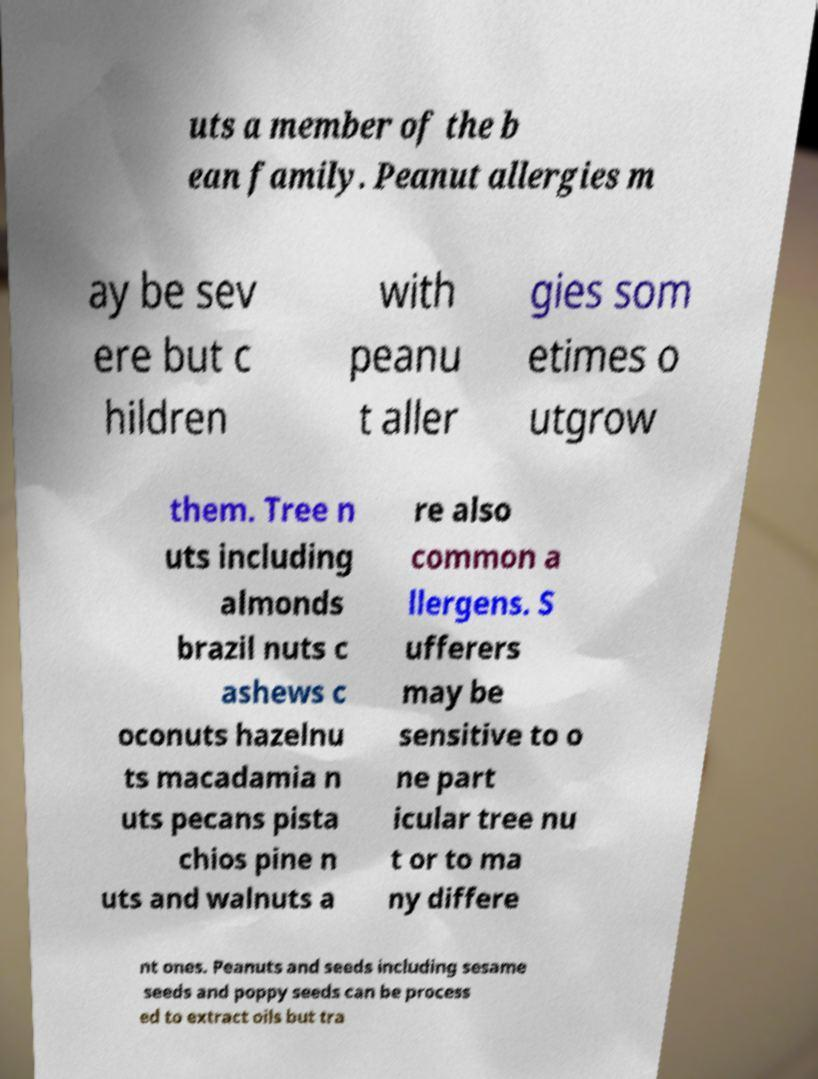I need the written content from this picture converted into text. Can you do that? uts a member of the b ean family. Peanut allergies m ay be sev ere but c hildren with peanu t aller gies som etimes o utgrow them. Tree n uts including almonds brazil nuts c ashews c oconuts hazelnu ts macadamia n uts pecans pista chios pine n uts and walnuts a re also common a llergens. S ufferers may be sensitive to o ne part icular tree nu t or to ma ny differe nt ones. Peanuts and seeds including sesame seeds and poppy seeds can be process ed to extract oils but tra 